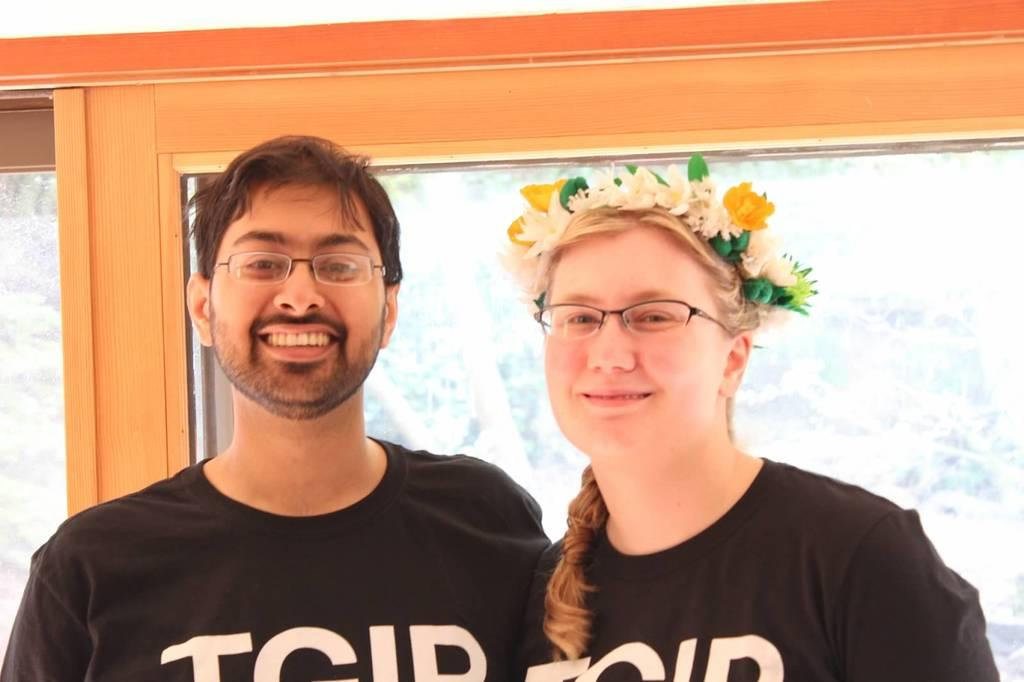Who can be seen in the foreground of the picture? There is a couple in the foreground of the picture. What are the couple doing in the picture? The couple is standing and smiling. What can be seen in the background of the picture? There is a glass in the background of the picture. What type of wall is visible in the top part of the picture? There is a wooden wall in the top part of the picture. What type of tramp can be seen jumping in the background of the picture? There is no tramp present in the image; it only features a couple standing and smiling, a glass in the background, and a wooden wall in the top part of the picture. 